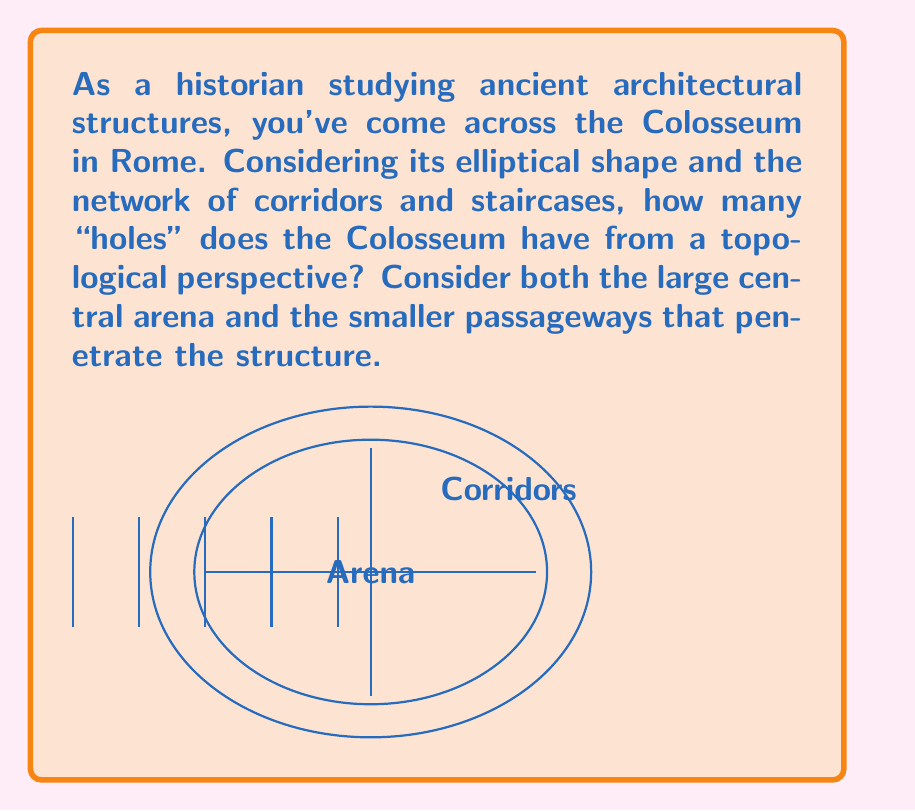Show me your answer to this math problem. To determine the number of topological holes in the Colosseum, we need to consider its fundamental structure from a topological perspective. Let's break this down step-by-step:

1) First, recall that in topology, a "hole" is any feature that prevents the space from being continuously deformed into a solid shape without tearing.

2) The Colosseum has a large central opening (the arena). This counts as one hole.

3) The elliptical structure of the Colosseum is essentially a thick ring when viewed from above. In topology, a ring (like a donut) has one hole. However, this is the same hole as the central arena, so we don't count it separately.

4) Now, consider the network of corridors and staircases. These passageways run through the structure, connecting the outside to the inside. Each of these passageways that goes completely through the structure (from outside to inside) creates an additional hole from a topological perspective.

5) The Colosseum had 80 entrance arches at ground level, each leading to a passageway that penetrated the entire structure. These are sometimes called "vomitoria".

6) Additionally, there were staircases and other corridors, but for our topological analysis, we only need to count those that create a complete passage from outside to inside.

7) Therefore, we have:
   - 1 hole for the central arena
   - 80 holes for the ground-level passageways (vomitoria)

8) The total number of topological holes is thus 1 + 80 = 81.

This high number of holes makes the Colosseum topologically equivalent to a very complex multi-torus, demonstrating the sophisticated architecture of ancient Roman structures.
Answer: 81 holes 